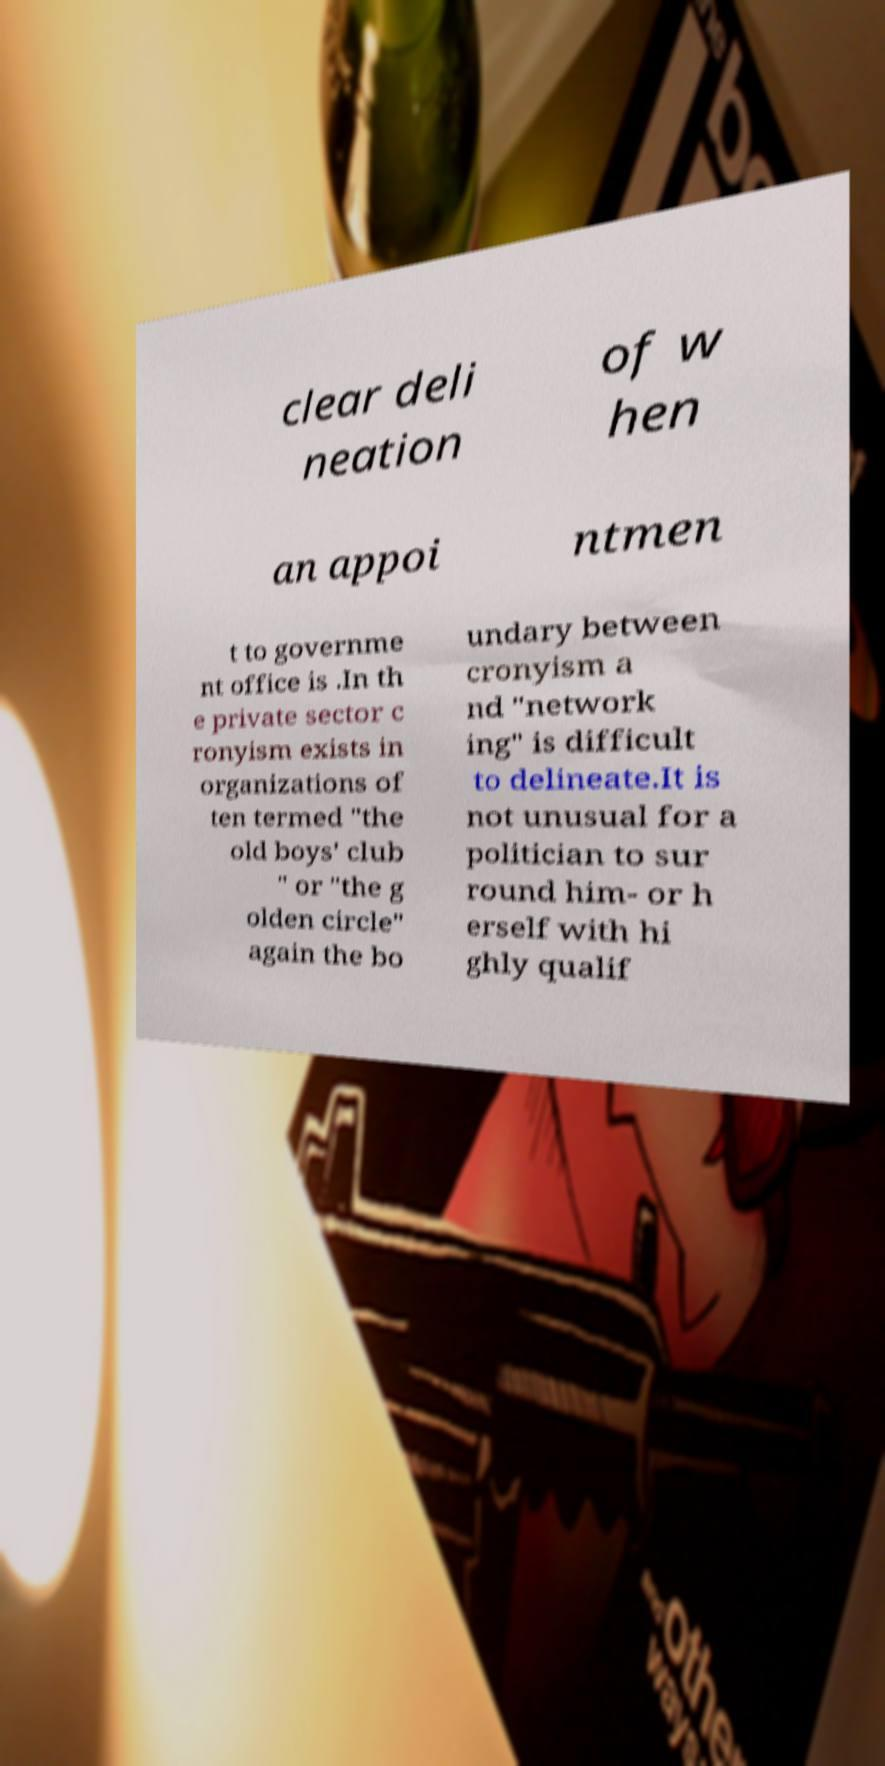Can you read and provide the text displayed in the image?This photo seems to have some interesting text. Can you extract and type it out for me? clear deli neation of w hen an appoi ntmen t to governme nt office is .In th e private sector c ronyism exists in organizations of ten termed "the old boys' club " or "the g olden circle" again the bo undary between cronyism a nd "network ing" is difficult to delineate.It is not unusual for a politician to sur round him- or h erself with hi ghly qualif 